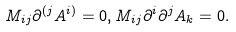Convert formula to latex. <formula><loc_0><loc_0><loc_500><loc_500>M _ { i j } \partial ^ { ( j } A ^ { i ) } = 0 , M _ { i j } \partial ^ { i } \partial ^ { j } A _ { k } = 0 .</formula> 